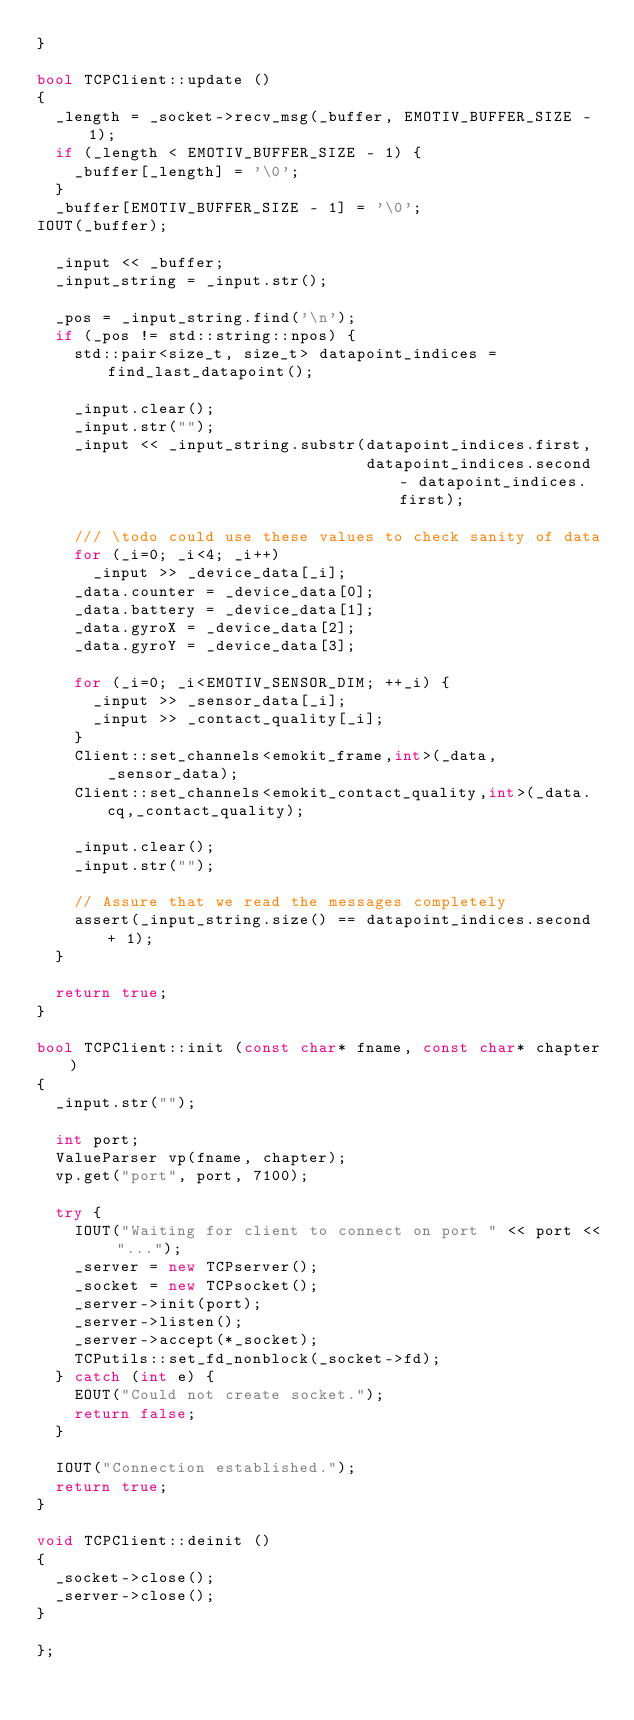<code> <loc_0><loc_0><loc_500><loc_500><_C++_>}

bool TCPClient::update ()
{
  _length = _socket->recv_msg(_buffer, EMOTIV_BUFFER_SIZE - 1);
  if (_length < EMOTIV_BUFFER_SIZE - 1) {
    _buffer[_length] = '\0';
  }
  _buffer[EMOTIV_BUFFER_SIZE - 1] = '\0';
IOUT(_buffer);

  _input << _buffer;
  _input_string = _input.str();
    
  _pos = _input_string.find('\n');
  if (_pos != std::string::npos) { 
    std::pair<size_t, size_t> datapoint_indices = find_last_datapoint();

    _input.clear();
    _input.str("");
    _input << _input_string.substr(datapoint_indices.first, 
                                   datapoint_indices.second - datapoint_indices.first);

    /// \todo could use these values to check sanity of data
    for (_i=0; _i<4; _i++)
      _input >> _device_data[_i];
    _data.counter = _device_data[0];
    _data.battery = _device_data[1];
    _data.gyroX = _device_data[2];
    _data.gyroY = _device_data[3];

    for (_i=0; _i<EMOTIV_SENSOR_DIM; ++_i) {
      _input >> _sensor_data[_i];
      _input >> _contact_quality[_i];
    }
    Client::set_channels<emokit_frame,int>(_data,_sensor_data);
    Client::set_channels<emokit_contact_quality,int>(_data.cq,_contact_quality);

    _input.clear();
    _input.str("");

    // Assure that we read the messages completely
    assert(_input_string.size() == datapoint_indices.second + 1);
  }

  return true;
}

bool TCPClient::init (const char* fname, const char* chapter)
{
  _input.str("");

  int port;
  ValueParser vp(fname, chapter);
  vp.get("port", port, 7100);

  try {
    IOUT("Waiting for client to connect on port " << port << "...");
    _server = new TCPserver();
    _socket = new TCPsocket();
    _server->init(port);
    _server->listen();
    _server->accept(*_socket);
    TCPutils::set_fd_nonblock(_socket->fd);
  } catch (int e) {
    EOUT("Could not create socket.");
    return false;
  }

  IOUT("Connection established.");
  return true;
}

void TCPClient::deinit ()
{
  _socket->close();
  _server->close();
}

};
</code> 